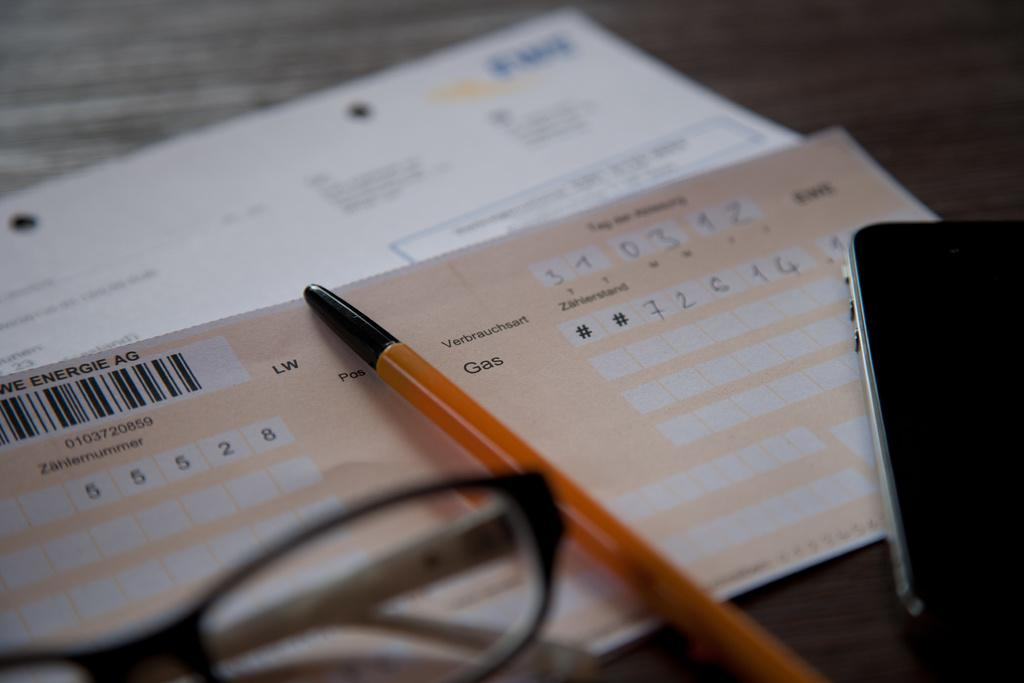Provide a one-sentence caption for the provided image. A German note about the gas bill lies on the counter under a pen. 